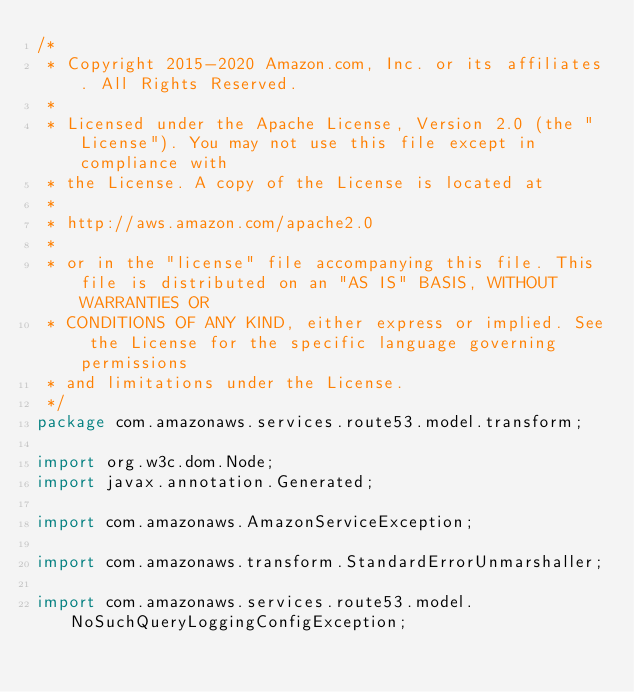<code> <loc_0><loc_0><loc_500><loc_500><_Java_>/*
 * Copyright 2015-2020 Amazon.com, Inc. or its affiliates. All Rights Reserved.
 * 
 * Licensed under the Apache License, Version 2.0 (the "License"). You may not use this file except in compliance with
 * the License. A copy of the License is located at
 * 
 * http://aws.amazon.com/apache2.0
 * 
 * or in the "license" file accompanying this file. This file is distributed on an "AS IS" BASIS, WITHOUT WARRANTIES OR
 * CONDITIONS OF ANY KIND, either express or implied. See the License for the specific language governing permissions
 * and limitations under the License.
 */
package com.amazonaws.services.route53.model.transform;

import org.w3c.dom.Node;
import javax.annotation.Generated;

import com.amazonaws.AmazonServiceException;

import com.amazonaws.transform.StandardErrorUnmarshaller;

import com.amazonaws.services.route53.model.NoSuchQueryLoggingConfigException;
</code> 